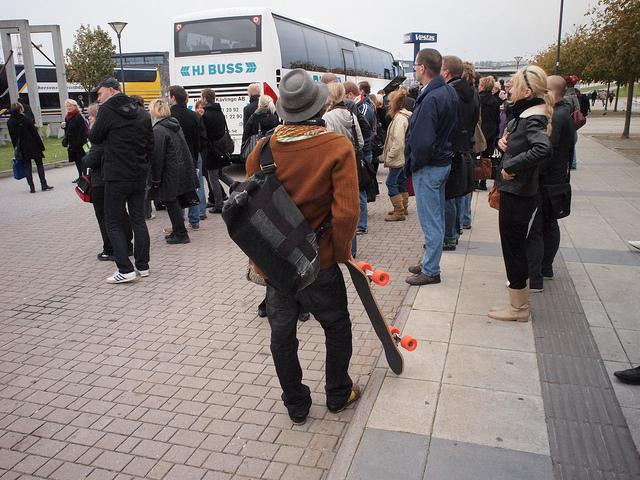What kind of bus is the white vehicle?

Choices:
A) tourist bus
B) school bus
C) double decker
D) public bus tourist bus 